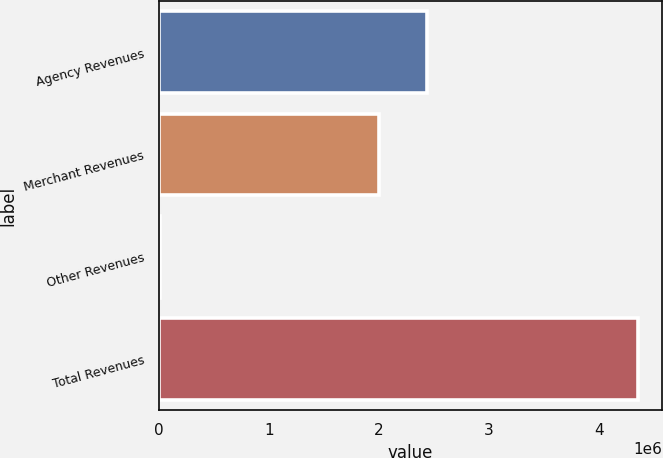<chart> <loc_0><loc_0><loc_500><loc_500><bar_chart><fcel>Agency Revenues<fcel>Merchant Revenues<fcel>Other Revenues<fcel>Total Revenues<nl><fcel>2.4388e+06<fcel>2.00443e+06<fcel>11925<fcel>4.35561e+06<nl></chart> 